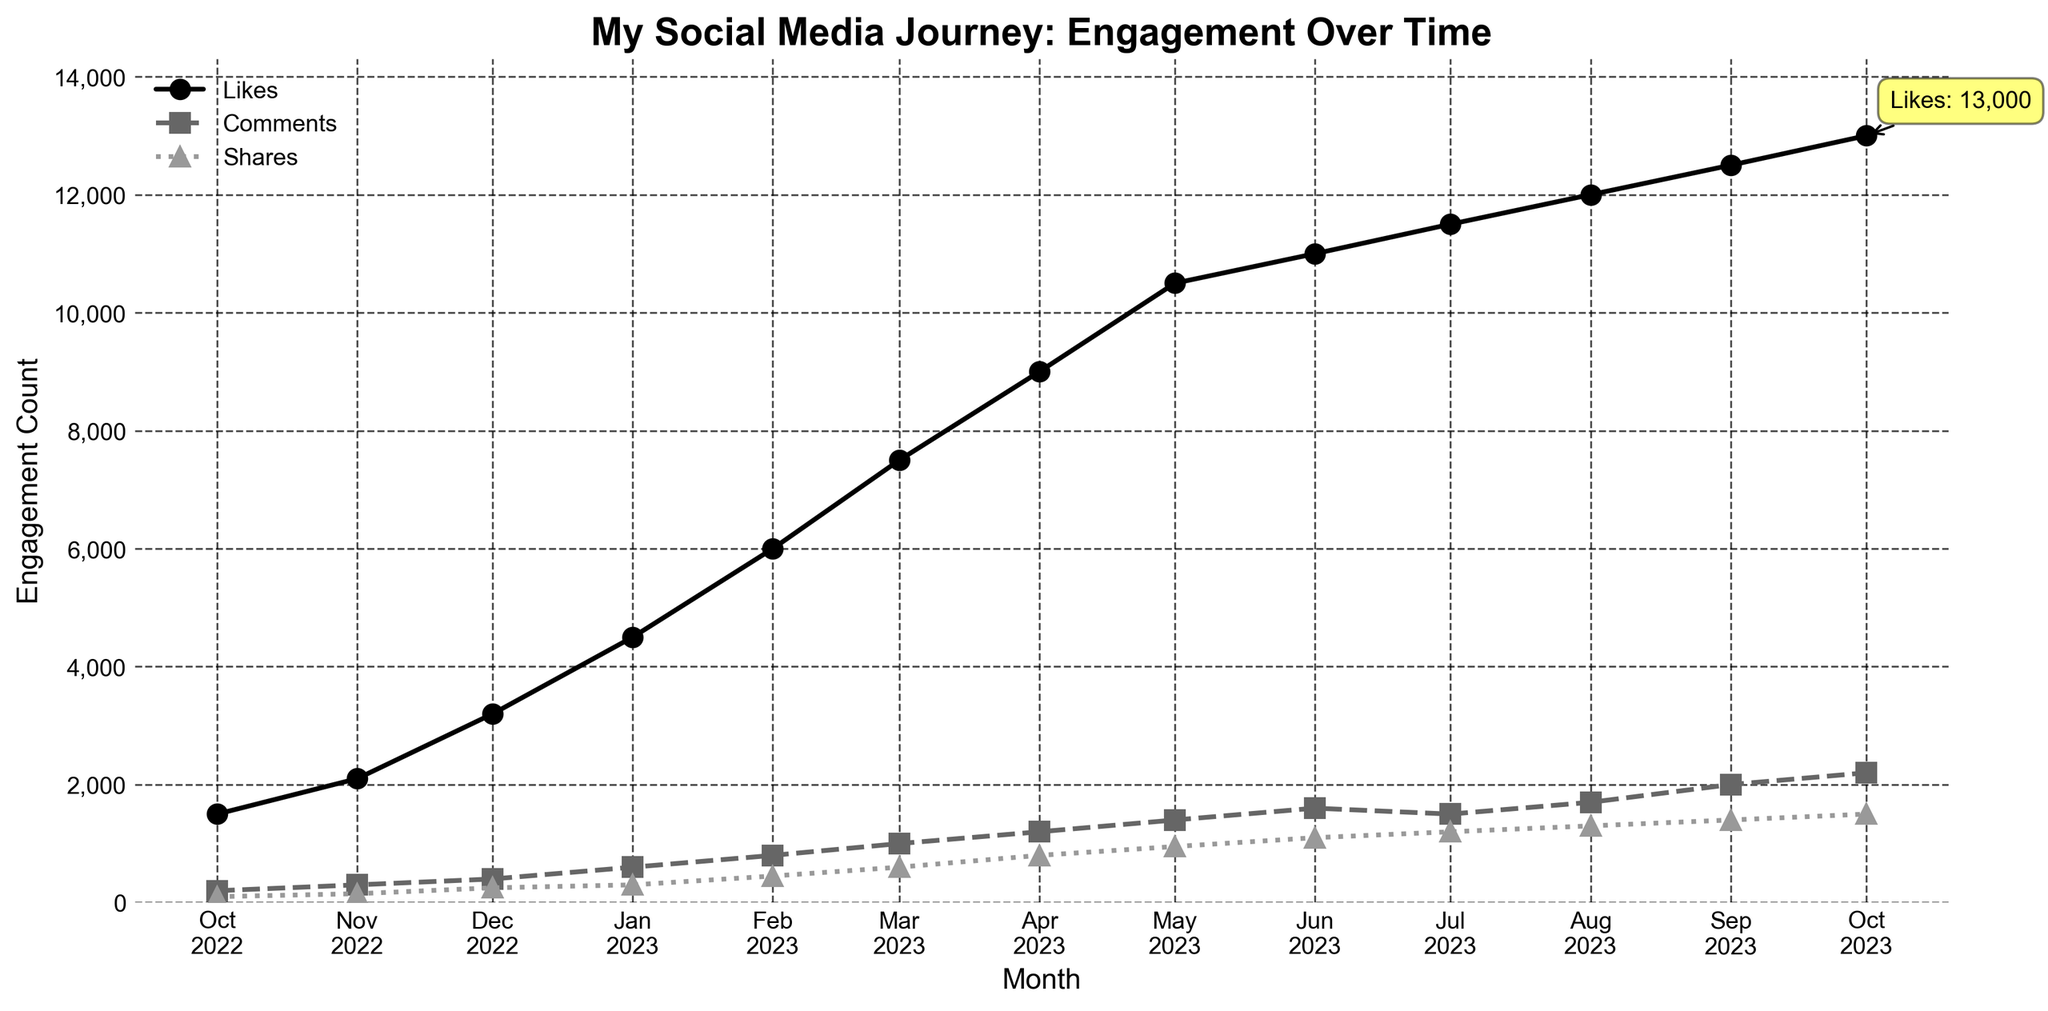What is the title of the plot? The title can be found at the top of the plot. It provides an overall description of the figure.
Answer: My Social Media Journey: Engagement Over Time What are the three different engagement metrics shown in the plot? There are three lines in the plot, each representing different metrics for engagement. These are indicated in the legend on the right side of the plot.
Answer: Likes, Comments, Shares In which month did the number of comments reach 1200? The number of comments can be identified by the square markers on the plot. Looking at the point where the y-axis value corresponds to 1200, you can trace vertically down to find the month.
Answer: April 2023 What is the range of 'Shares' over the past year? To find the range, subtract the minimum value of shares from the maximum value. The earliest and latest values shown in the plot will help identify this.
Answer: 1500 - 100 = 1400 Which month shows the highest number of total engagements (sum of Likes, Comments, Shares)? To find this, sum the values corresponding to Likes, Comments, and Shares for each month and compare them.
Answer: October 2023 Between which two consecutive months did 'Likes' see the largest increase? Calculating the difference in Likes numbers between each pair of consecutive months will identify the largest increase.
Answer: February to March 2023 How many months does 'Comments' stay above 1000? Identify the points where Comments (square markers) are above 1000 and count the corresponding months.
Answer: 7 months (from March 2023 to October 2023) During which month was the engagement for 'Likes' equal to 10500? Find the point on the plot where the y-axis value for Likes matches 10500 and note the corresponding month.
Answer: May 2023 What is the average number of 'Shares' over the past year? Summing up all the shares values and dividing by the number of data points (12 months) will yield the average.
Answer: (100 + 150 + 250 + 300 + 450 + 600 + 800 + 950 + 1100 + 1200 + 1300 + 1400 + 1500) / 12 = 883.33 How does the trend in 'Comments' change over the last four months? Examine the line with square markers and describe how it changes from July 2023 to October 2023.
Answer: Increasing steadily 